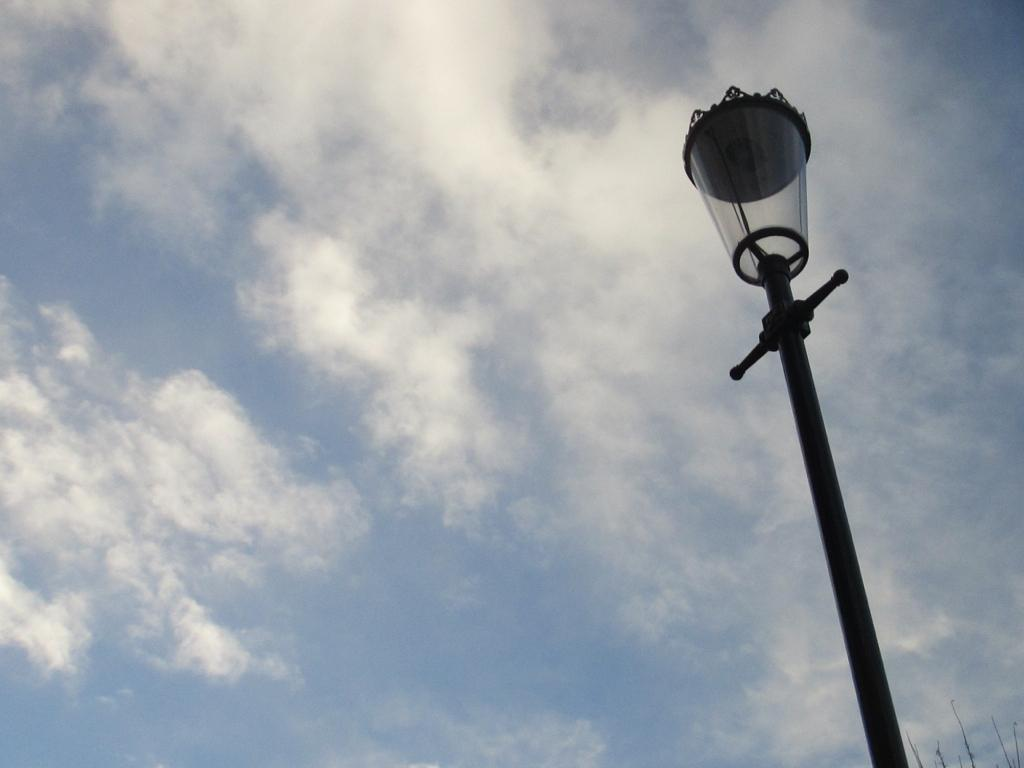What type of structure can be seen in the image? A lamp post is visible in the image. What can be seen in the sky at the top of the image? Clouds are visible in the sky at the top of the image. What type of stamp is on the lamp post in the image? There is no stamp present on the lamp post in the image. What type of house is visible in the image? There is no house visible in the image; it only features a lamp post and clouds in the sky. 